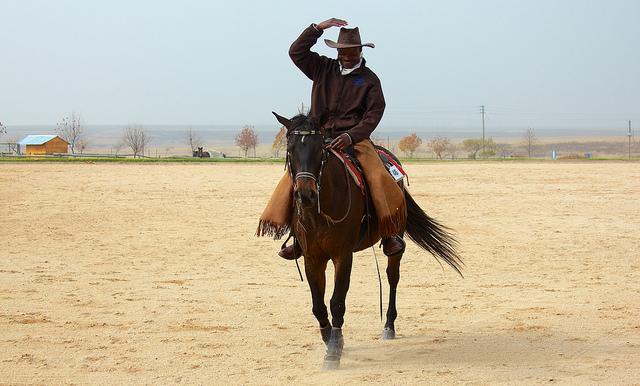What hand is in the air?
Answer briefly. Right. Is the horse trained?
Quick response, please. Yes. What is the rider dressed as?
Give a very brief answer. Cowboy. 